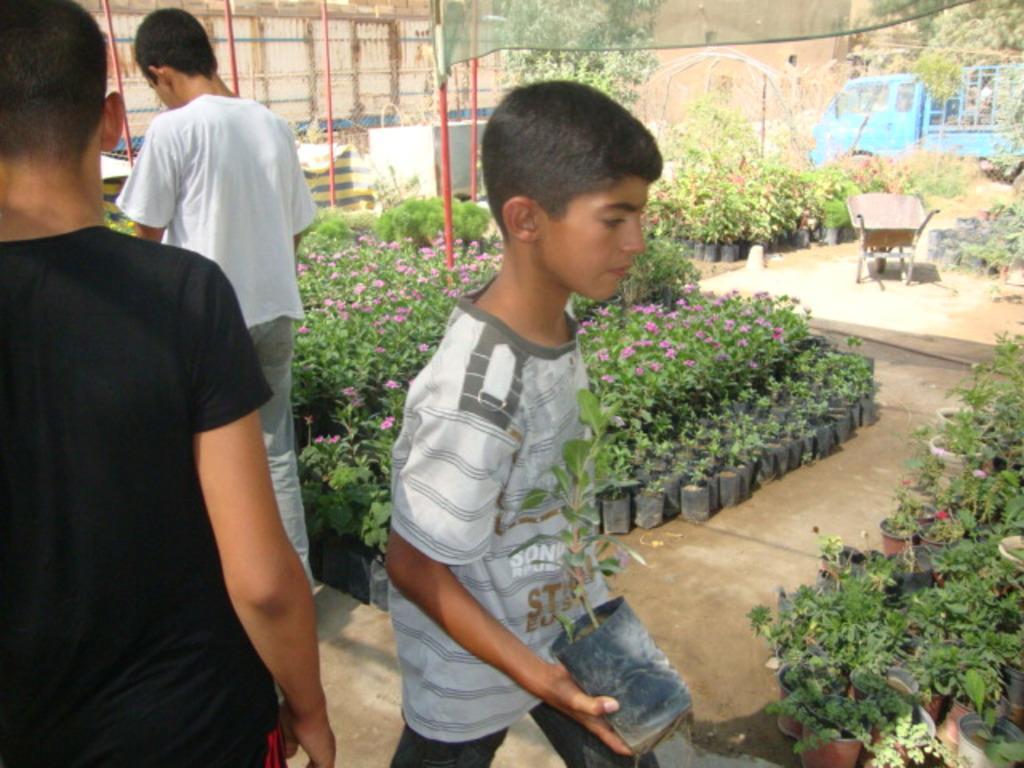How would you summarize this image in a sentence or two? In this image I can see a person wearing black colored t shirt and another person wearing grey colored t shirt is standing and holding a plant in his hand. In the background I can see few plants, few flowers which are pink in color, a person's standing, a blue colored vehicle, few red colored poles, a trolley and the green colored net. 